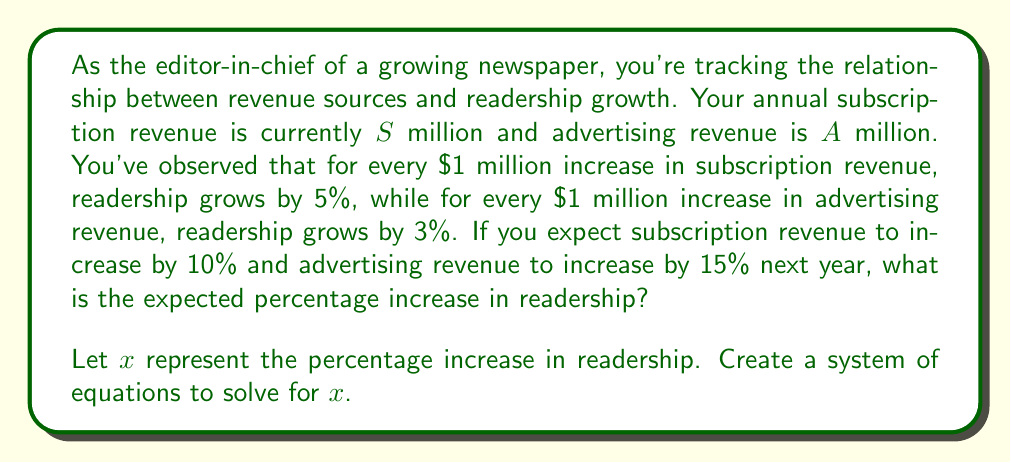Could you help me with this problem? Let's approach this problem step-by-step:

1) First, we need to set up equations based on the given information:

   For subscription revenue: $0.05S = 0.5x$
   (5% growth per $1 million, so $0.05S$ million increase leads to $0.5x$% growth)

   For advertising revenue: $0.03A = 0.3x$
   (3% growth per $1 million, so $0.03A$ million increase leads to $0.3x$% growth)

2) Now, we need to account for the expected increases in revenue:
   
   Subscription revenue increase: $0.1S$ (10% of $S$)
   Advertising revenue increase: $0.15A$ (15% of $A$)

3) Substituting these into our equations:

   $0.05(0.1S) = 0.5x$
   $0.03(0.15A) = 0.3x$

4) Simplify:

   $0.005S = 0.5x$
   $0.0045A = 0.3x$

5) Now we have a system of two equations:

   $$\begin{cases}
   0.005S = 0.5x \\
   0.0045A = 0.3x
   \end{cases}$$

6) Add these equations:

   $0.005S + 0.0045A = 0.8x$

7) The left side of this equation represents the total expected increase in readership. Therefore:

   $x = \frac{0.005S + 0.0045A}{0.8}$

8) To get the percentage, multiply by 100:

   $x\% = \frac{0.005S + 0.0045A}{0.8} \times 100\%$

   $= (0.00625S + 0.005625A)\%$

This formula gives us the expected percentage increase in readership based on the current subscription revenue ($S$) and advertising revenue ($A$).
Answer: The expected percentage increase in readership is $(0.00625S + 0.005625A)\%$, where $S$ is the current subscription revenue in millions and $A$ is the current advertising revenue in millions. 